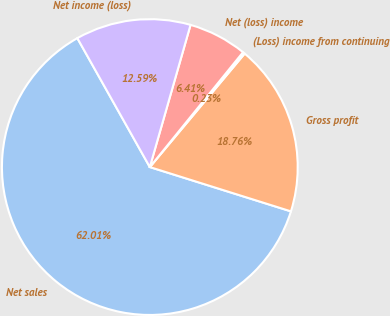Convert chart. <chart><loc_0><loc_0><loc_500><loc_500><pie_chart><fcel>Net sales<fcel>Gross profit<fcel>(Loss) income from continuing<fcel>Net (loss) income<fcel>Net income (loss)<nl><fcel>62.0%<fcel>18.76%<fcel>0.23%<fcel>6.41%<fcel>12.59%<nl></chart> 